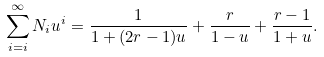<formula> <loc_0><loc_0><loc_500><loc_500>\sum _ { i = i } ^ { \infty } N _ { i } u ^ { i } = \frac { 1 } { 1 + ( 2 r - 1 ) u } + \frac { r } { 1 - u } + \frac { r - 1 } { 1 + u } .</formula> 